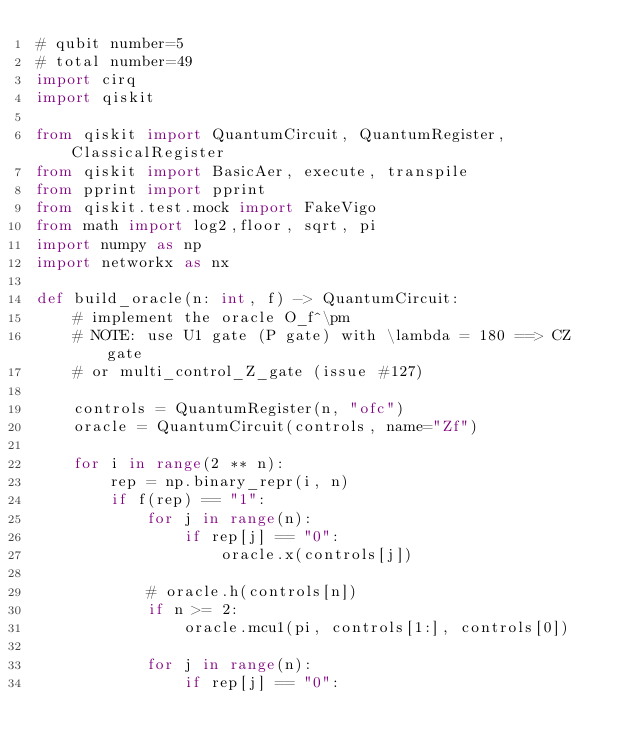<code> <loc_0><loc_0><loc_500><loc_500><_Python_># qubit number=5
# total number=49
import cirq
import qiskit

from qiskit import QuantumCircuit, QuantumRegister, ClassicalRegister
from qiskit import BasicAer, execute, transpile
from pprint import pprint
from qiskit.test.mock import FakeVigo
from math import log2,floor, sqrt, pi
import numpy as np
import networkx as nx

def build_oracle(n: int, f) -> QuantumCircuit:
    # implement the oracle O_f^\pm
    # NOTE: use U1 gate (P gate) with \lambda = 180 ==> CZ gate
    # or multi_control_Z_gate (issue #127)

    controls = QuantumRegister(n, "ofc")
    oracle = QuantumCircuit(controls, name="Zf")

    for i in range(2 ** n):
        rep = np.binary_repr(i, n)
        if f(rep) == "1":
            for j in range(n):
                if rep[j] == "0":
                    oracle.x(controls[j])

            # oracle.h(controls[n])
            if n >= 2:
                oracle.mcu1(pi, controls[1:], controls[0])

            for j in range(n):
                if rep[j] == "0":</code> 